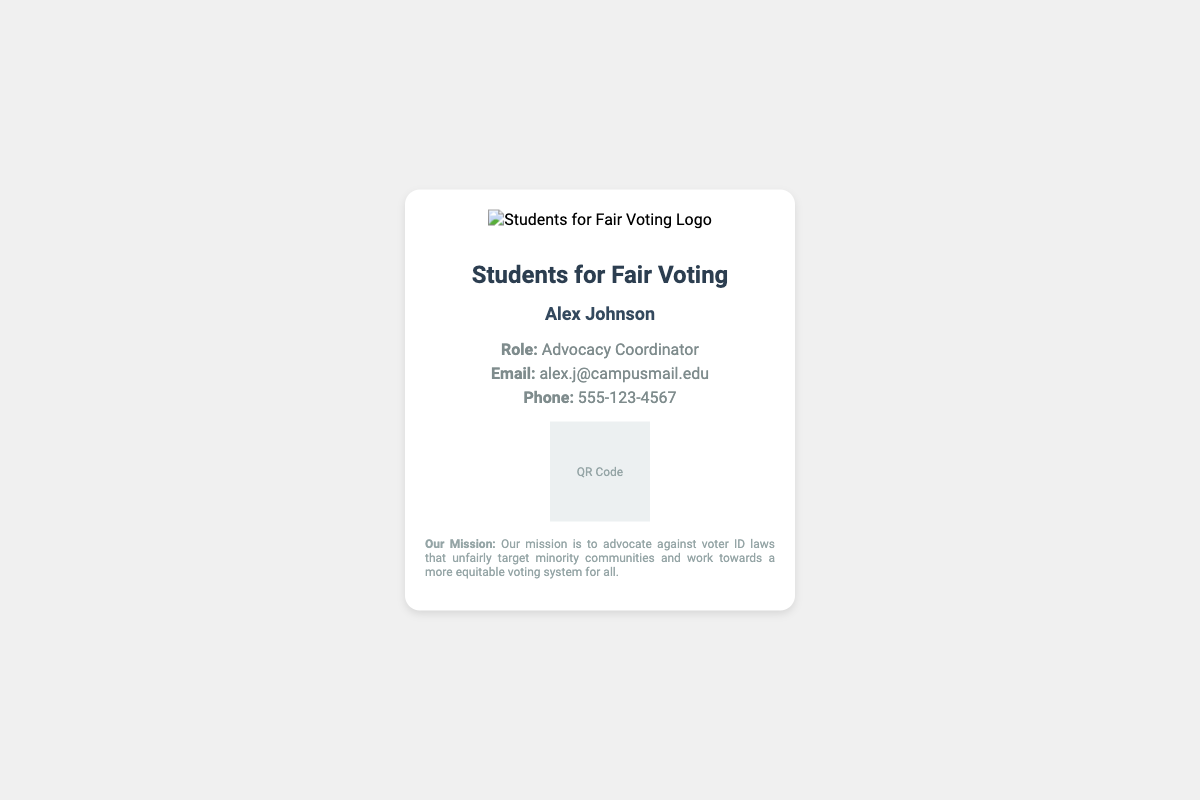What is the name of the advocacy group? The name of the advocacy group is prominently displayed at the top of the card.
Answer: Students for Fair Voting Who is the Advocacy Coordinator? The card lists the name of the person in this role underneath the group's name.
Answer: Alex Johnson What is the email address provided? The email address is displayed in the contact information section.
Answer: alex.j@campusmail.edu What is the phone number listed? The card includes a contact phone number in the information section.
Answer: 555-123-4567 What is the mission of the group? The group's mission statement is provided at the bottom of the card.
Answer: Advocate against voter ID laws What does the QR code link to? The QR code is mentioned as linking to the group's mission statement and upcoming events.
Answer: Group's mission statement and upcoming events What color is the card's background? The background color can be observed throughout the card design.
Answer: White How many words are in the name of the advocacy group? The name can be counted to determine the number of words.
Answer: Four What is the size of the logo displayed? The size of the logo is specified in the document.
Answer: 100 pixels What type of document is this? The format and elements included identify the nature of this document.
Answer: Membership card 